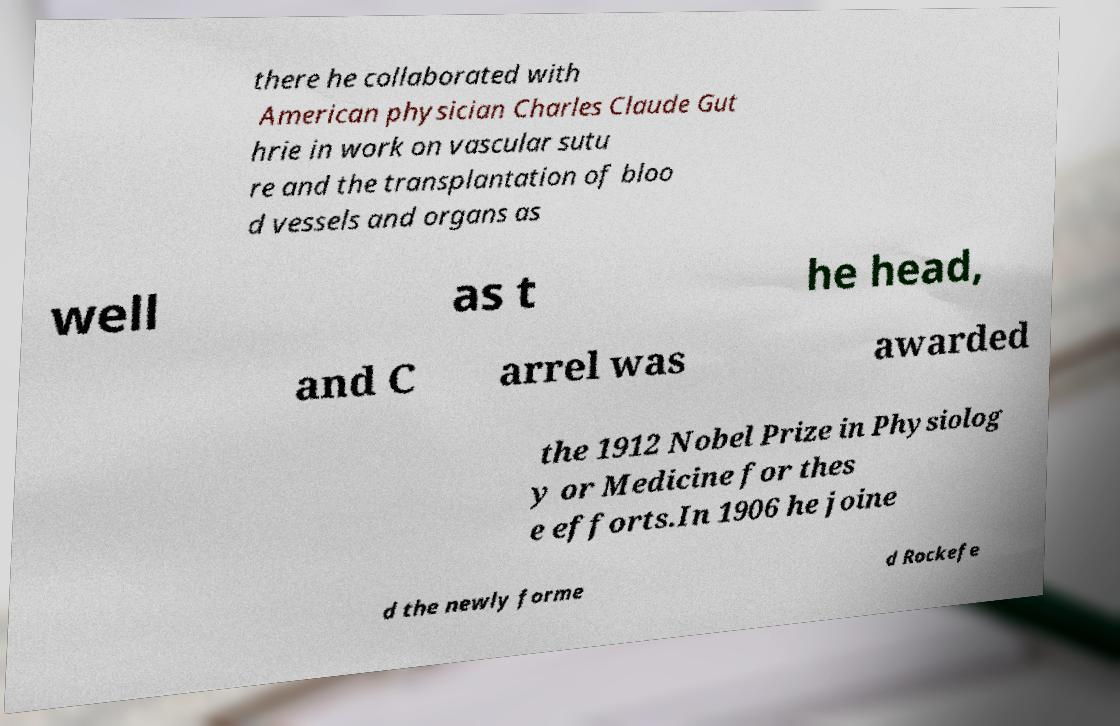I need the written content from this picture converted into text. Can you do that? there he collaborated with American physician Charles Claude Gut hrie in work on vascular sutu re and the transplantation of bloo d vessels and organs as well as t he head, and C arrel was awarded the 1912 Nobel Prize in Physiolog y or Medicine for thes e efforts.In 1906 he joine d the newly forme d Rockefe 